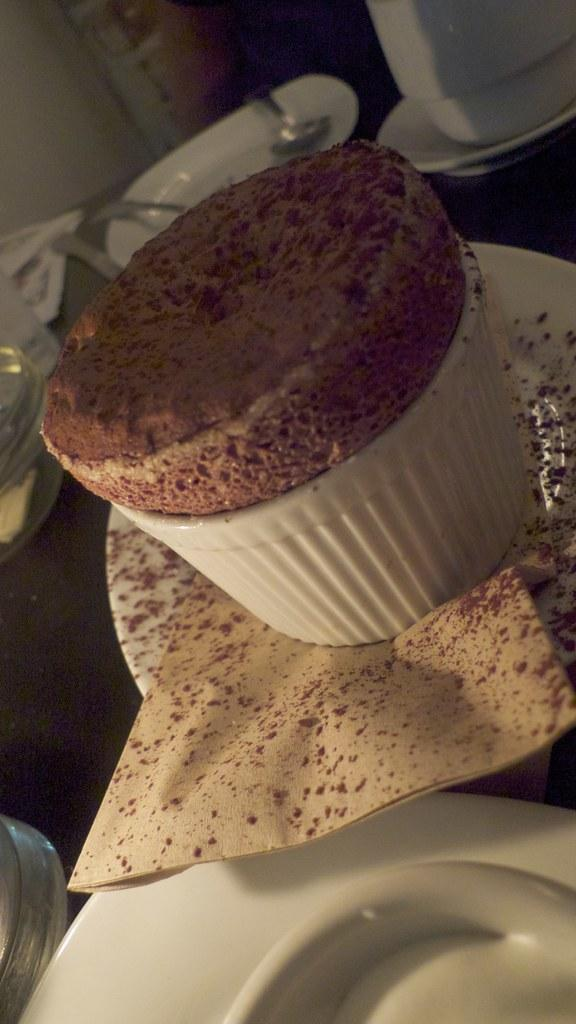What type of food is shown in the image? There is a cupcake in the image. What color are the plates in the image? The plates in the image are white. What utensils can be seen in the image? There are spoons visible in the image. What type of juice is being served in the yard in the image? There is no juice or yard present in the image; it only shows a cupcake, white plates, and spoons. 